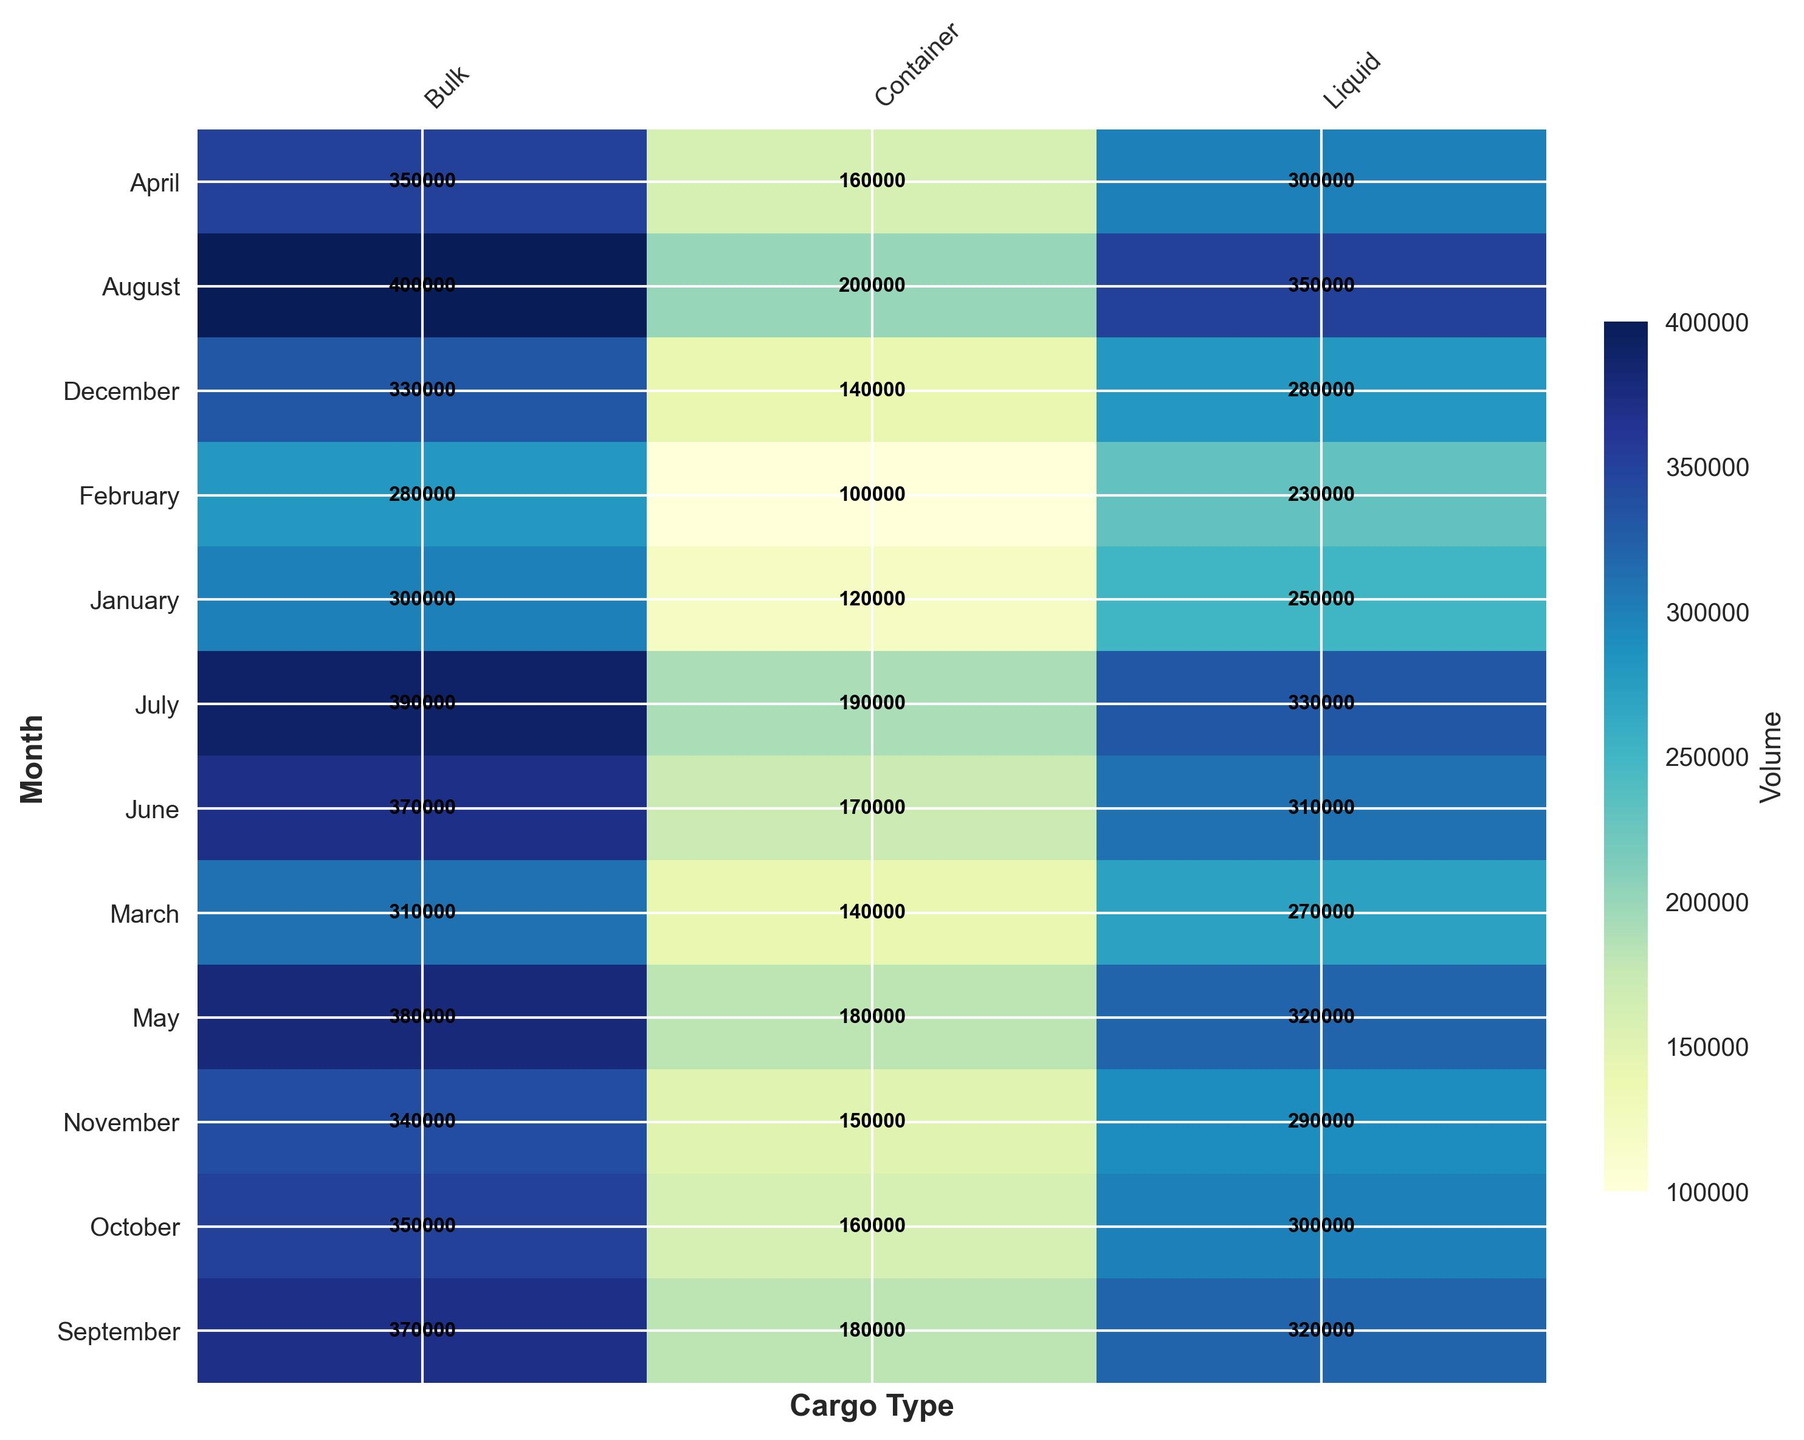What month sees the highest volume of Liquid cargo? Look at the Liquid column and find the cell with the highest volume. The darkest blue cell in this column represents the highest volume.
Answer: August Which Cargo_Type has the lowest overall volume in October? Check the values in the October row across all cargo types. Identify the lowest numerical value and the corresponding Cargo_Type.
Answer: Container Compare the volume of Bulk cargo between February and September. Which month has more volume? Look at the Bulk column and compare the volume in the February row with the volume in the September row. September's value is higher.
Answer: September What is the average volume of Container cargo across July, August, and September? Sum the volumes for Container cargo in July, August, and September (190000 + 200000 + 180000) and divide by 3 to find the average.
Answer: 190000 Which month sees the biggest increase in Container cargo volume compared to the previous month? Calculate the monthly differences in the Container column and identify the month with the largest positive difference. From June to July, the volume increases by 20000 (190000 - 170000).
Answer: July How much more Bulk cargo volume is there in May compared to March? Find the difference between the Bulk cargo volume in May (380000) and March (310000).
Answer: 70000 Find the month with the least variation in cargo volumes across different Cargo_Types. Find the month where the values for Container, Bulk, and Liquid are closest to each other. Calculate the range (maximum - minimum) for each month. November has the smallest range (340000 - 150000).
Answer: November Which Cargo_Type shows the most consistent monthly volume? Assess the variation in the volume of each Cargo_Type across the months. Container volumes show a more consistent trend compared to Bulk and Liquid.
Answer: Container Which month has the highest total cargo volume when combining Container, Bulk, and Liquid? Sum the Container, Bulk, and Liquid volumes for each month and find the month with the highest total. August has the highest combined volume (200000 + 400000 + 350000).
Answer: August During the first quarter of the year (Jan-Mar), which Cargo_Type has the highest average volume? Calculate the average volume for each Cargo_Type in January, February, and March. Bulk has the highest average volume (300000 + 280000 + 310000) / 3.
Answer: Bulk 